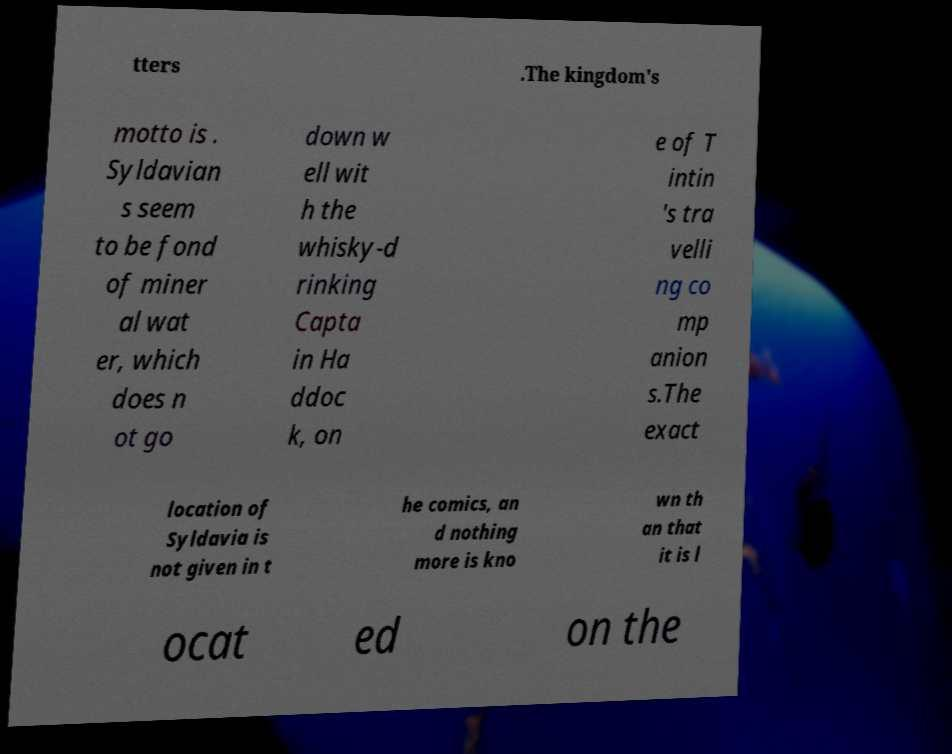Please identify and transcribe the text found in this image. tters .The kingdom's motto is . Syldavian s seem to be fond of miner al wat er, which does n ot go down w ell wit h the whisky-d rinking Capta in Ha ddoc k, on e of T intin 's tra velli ng co mp anion s.The exact location of Syldavia is not given in t he comics, an d nothing more is kno wn th an that it is l ocat ed on the 